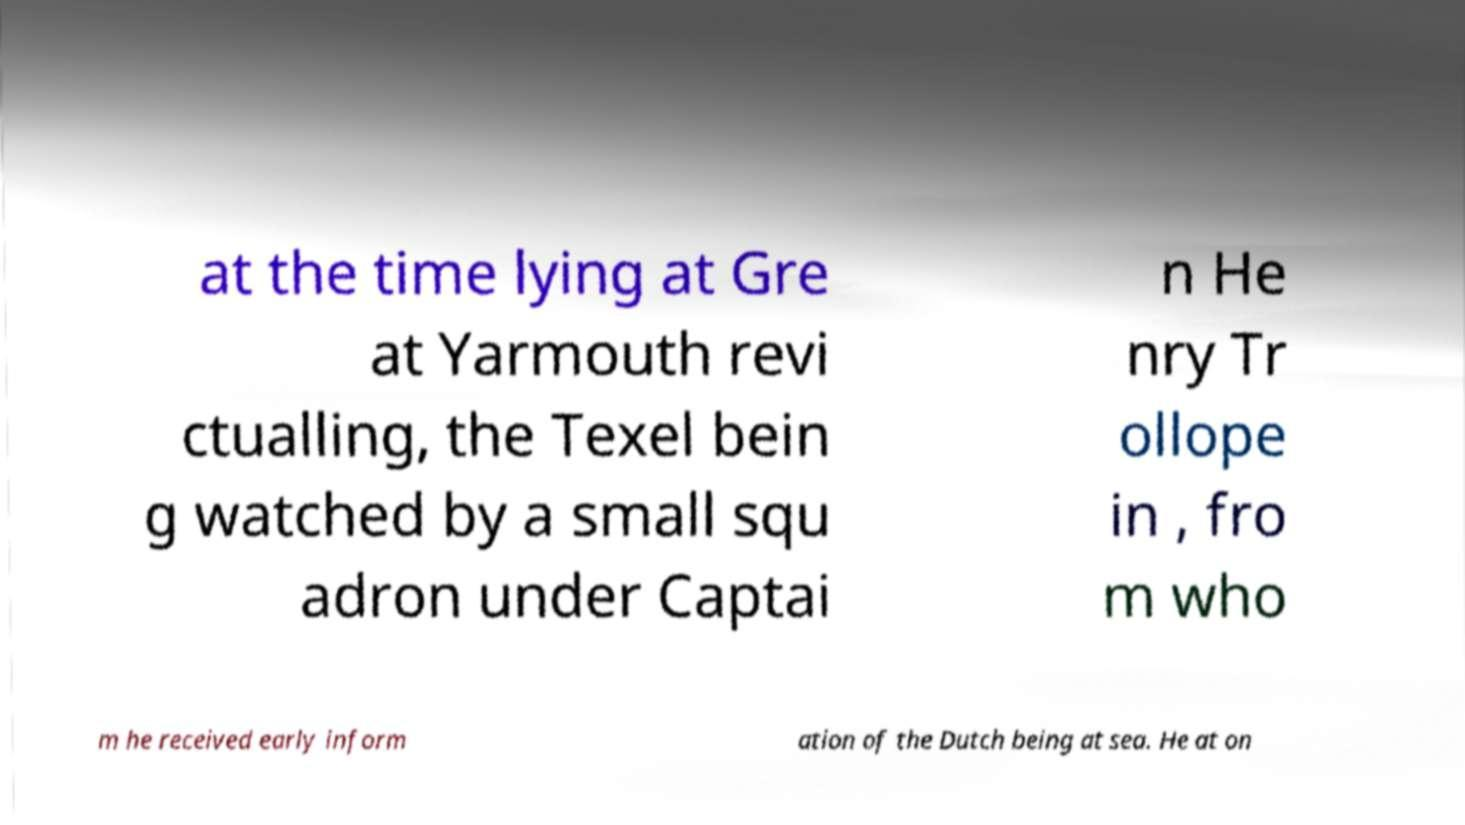Could you extract and type out the text from this image? at the time lying at Gre at Yarmouth revi ctualling, the Texel bein g watched by a small squ adron under Captai n He nry Tr ollope in , fro m who m he received early inform ation of the Dutch being at sea. He at on 